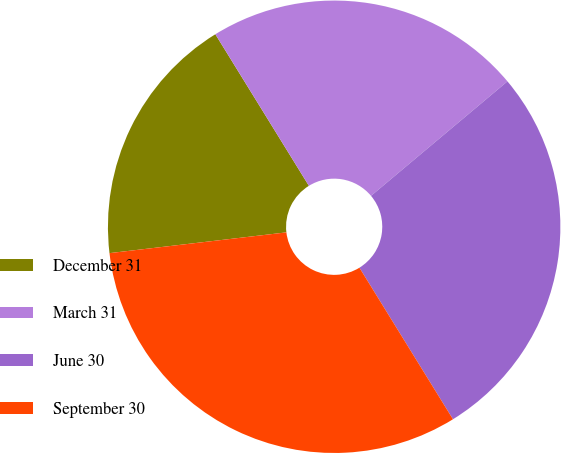<chart> <loc_0><loc_0><loc_500><loc_500><pie_chart><fcel>December 31<fcel>March 31<fcel>June 30<fcel>September 30<nl><fcel>18.06%<fcel>22.69%<fcel>27.31%<fcel>31.94%<nl></chart> 